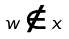Convert formula to latex. <formula><loc_0><loc_0><loc_500><loc_500>w \notin x</formula> 